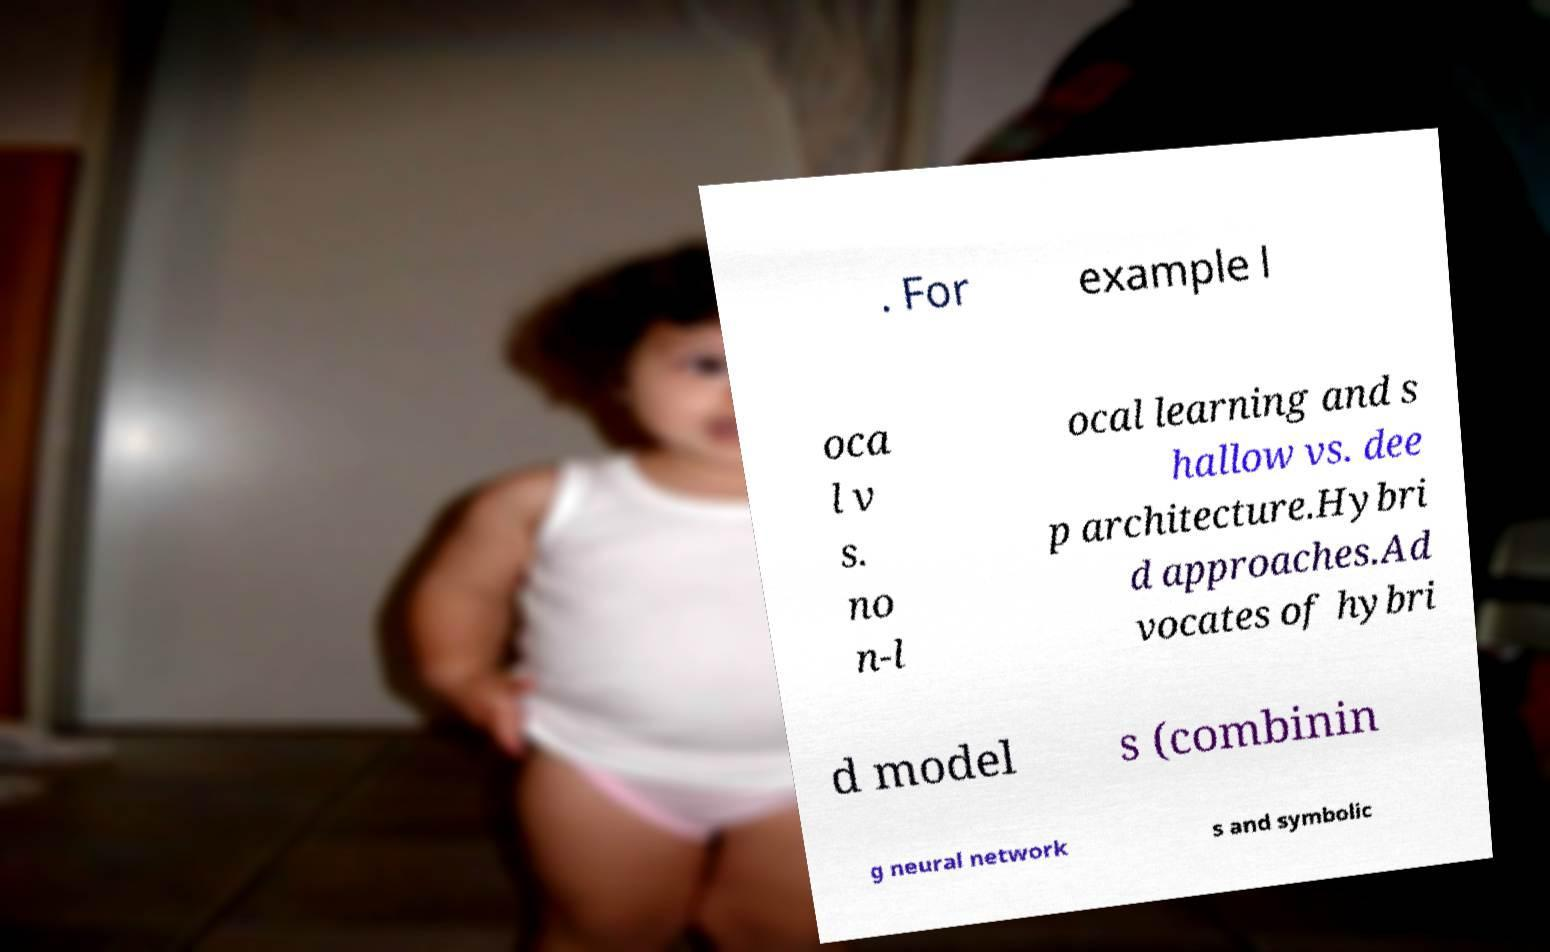What messages or text are displayed in this image? I need them in a readable, typed format. . For example l oca l v s. no n-l ocal learning and s hallow vs. dee p architecture.Hybri d approaches.Ad vocates of hybri d model s (combinin g neural network s and symbolic 